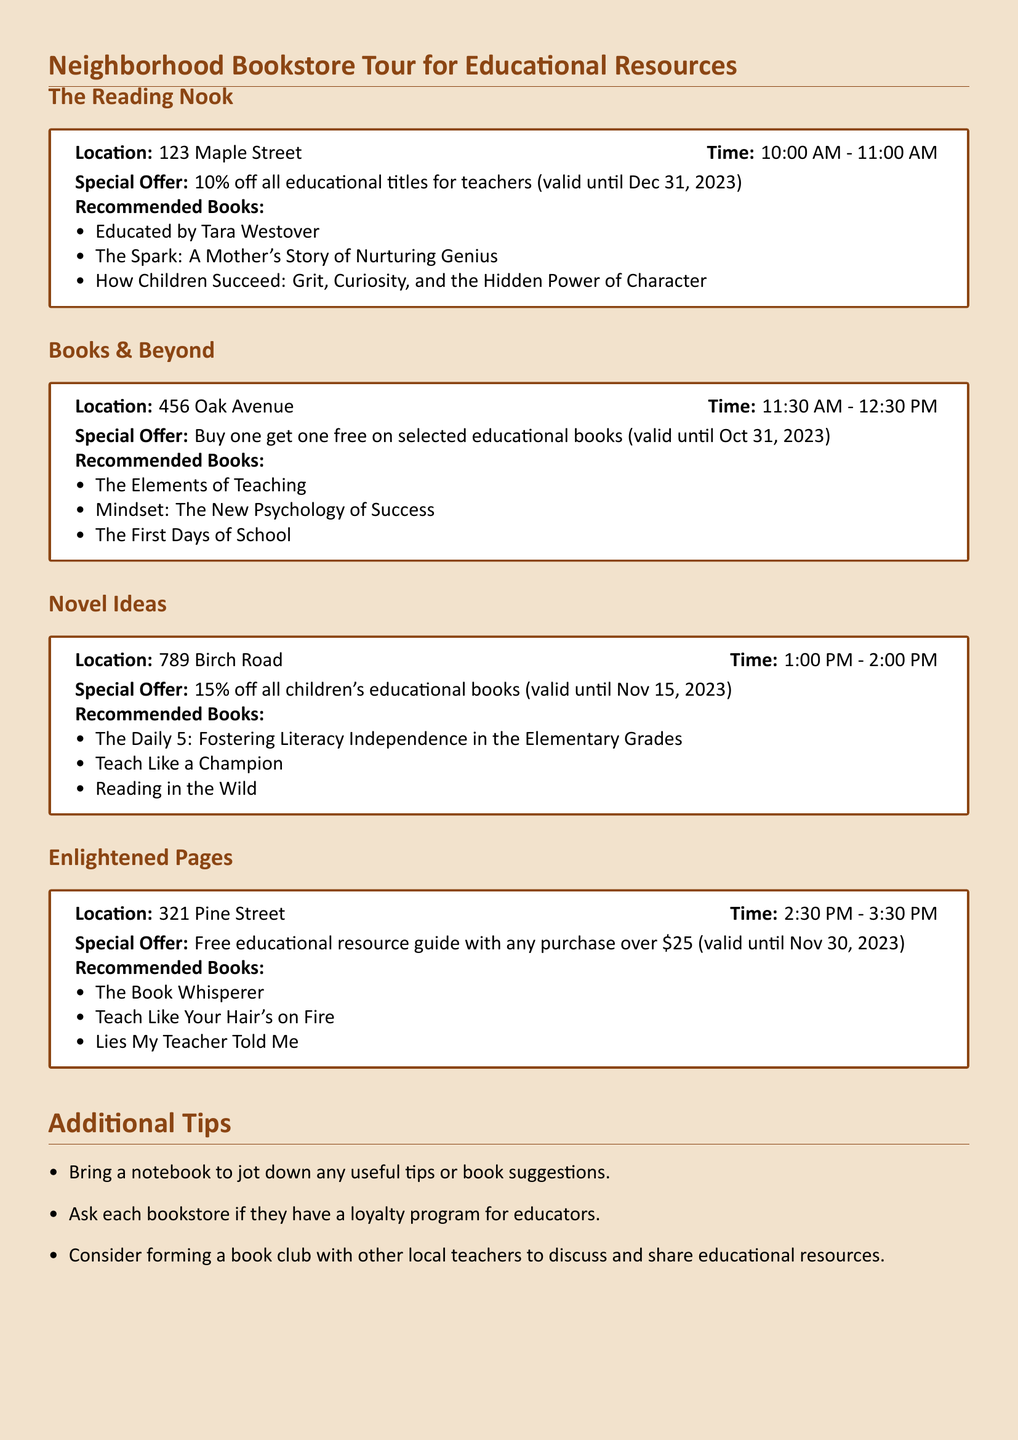What is the first bookstore on the tour? The first bookstore listed in the document is The Reading Nook, which is mentioned at the beginning of the itinerary.
Answer: The Reading Nook What is the location of Books & Beyond? The document specifies the address of Books & Beyond, which is mentioned in the itinerary.
Answer: 456 Oak Avenue What is the time slot for the visit to Novel Ideas? The time for the visit to Novel Ideas is clearly stated in the document.
Answer: 1:00 PM - 2:00 PM What type of discount does Enlightened Pages offer? The offer at Enlightened Pages is highlighted in the document regarding what customers can receive with specific purchases.
Answer: Free educational resource guide with any purchase over $25 How long is the special offer at The Reading Nook valid? The validity period for the special offer at The Reading Nook is provided in the document, indicating when it can be used.
Answer: Until Dec 31, 2023 Which bookstore offers a buy one get one free deal? This information requires recalling specific offers listed in the itinerary.
Answer: Books & Beyond What should you bring to the bookstore tour? The additional tips at the end of the document suggest something to bring for jotting down notes.
Answer: A notebook What is the last bookstore listed in the itinerary? The final bookstore mentioned gives an understanding of the order of visits in the itinerary.
Answer: Enlightened Pages 